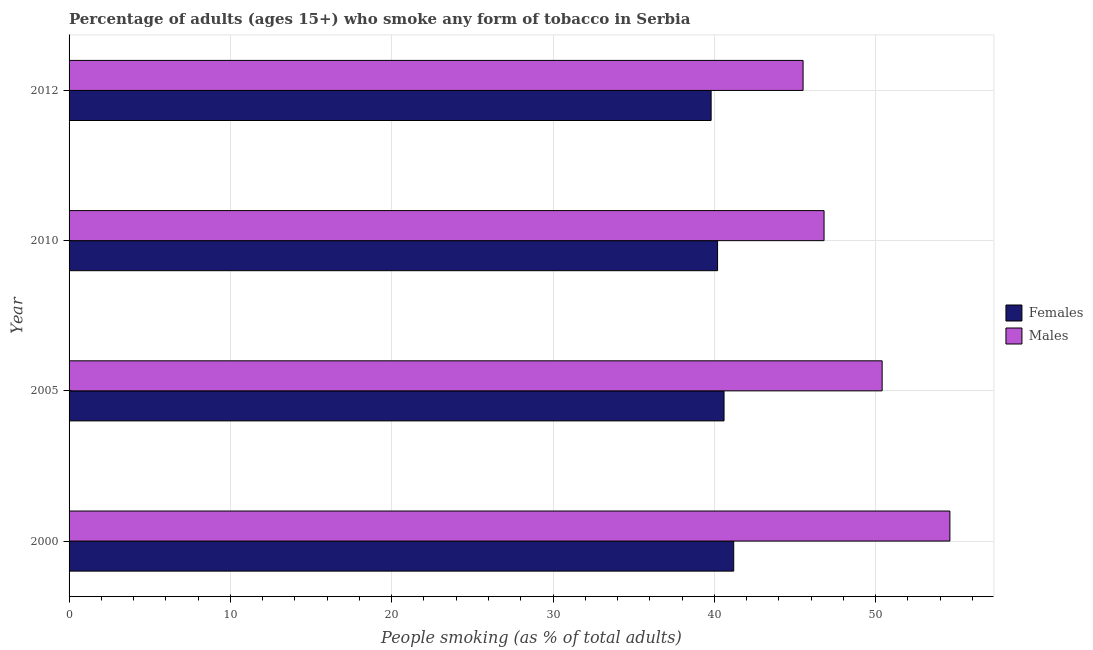How many different coloured bars are there?
Provide a succinct answer. 2. Are the number of bars per tick equal to the number of legend labels?
Give a very brief answer. Yes. What is the label of the 4th group of bars from the top?
Your answer should be very brief. 2000. What is the percentage of males who smoke in 2012?
Your answer should be compact. 45.5. Across all years, what is the maximum percentage of females who smoke?
Offer a very short reply. 41.2. Across all years, what is the minimum percentage of females who smoke?
Keep it short and to the point. 39.8. In which year was the percentage of males who smoke minimum?
Offer a terse response. 2012. What is the total percentage of males who smoke in the graph?
Give a very brief answer. 197.3. What is the difference between the percentage of females who smoke in 2005 and the percentage of males who smoke in 2012?
Offer a very short reply. -4.9. What is the average percentage of females who smoke per year?
Offer a very short reply. 40.45. What is the difference between the highest and the second highest percentage of females who smoke?
Ensure brevity in your answer.  0.6. What does the 1st bar from the top in 2000 represents?
Provide a short and direct response. Males. What does the 2nd bar from the bottom in 2010 represents?
Offer a terse response. Males. Are all the bars in the graph horizontal?
Make the answer very short. Yes. Does the graph contain grids?
Offer a terse response. Yes. Where does the legend appear in the graph?
Provide a succinct answer. Center right. How are the legend labels stacked?
Your answer should be compact. Vertical. What is the title of the graph?
Ensure brevity in your answer.  Percentage of adults (ages 15+) who smoke any form of tobacco in Serbia. Does "Highest 10% of population" appear as one of the legend labels in the graph?
Your answer should be very brief. No. What is the label or title of the X-axis?
Give a very brief answer. People smoking (as % of total adults). What is the People smoking (as % of total adults) of Females in 2000?
Your answer should be very brief. 41.2. What is the People smoking (as % of total adults) of Males in 2000?
Give a very brief answer. 54.6. What is the People smoking (as % of total adults) of Females in 2005?
Offer a terse response. 40.6. What is the People smoking (as % of total adults) in Males in 2005?
Your answer should be very brief. 50.4. What is the People smoking (as % of total adults) of Females in 2010?
Give a very brief answer. 40.2. What is the People smoking (as % of total adults) of Males in 2010?
Your answer should be compact. 46.8. What is the People smoking (as % of total adults) of Females in 2012?
Make the answer very short. 39.8. What is the People smoking (as % of total adults) of Males in 2012?
Your response must be concise. 45.5. Across all years, what is the maximum People smoking (as % of total adults) in Females?
Give a very brief answer. 41.2. Across all years, what is the maximum People smoking (as % of total adults) in Males?
Give a very brief answer. 54.6. Across all years, what is the minimum People smoking (as % of total adults) of Females?
Make the answer very short. 39.8. Across all years, what is the minimum People smoking (as % of total adults) of Males?
Provide a short and direct response. 45.5. What is the total People smoking (as % of total adults) in Females in the graph?
Your response must be concise. 161.8. What is the total People smoking (as % of total adults) of Males in the graph?
Offer a very short reply. 197.3. What is the difference between the People smoking (as % of total adults) in Males in 2000 and that in 2010?
Provide a short and direct response. 7.8. What is the difference between the People smoking (as % of total adults) of Females in 2005 and that in 2010?
Provide a short and direct response. 0.4. What is the difference between the People smoking (as % of total adults) in Females in 2005 and that in 2012?
Make the answer very short. 0.8. What is the difference between the People smoking (as % of total adults) in Males in 2005 and that in 2012?
Provide a short and direct response. 4.9. What is the difference between the People smoking (as % of total adults) in Females in 2010 and that in 2012?
Your response must be concise. 0.4. What is the difference between the People smoking (as % of total adults) in Males in 2010 and that in 2012?
Ensure brevity in your answer.  1.3. What is the difference between the People smoking (as % of total adults) of Females in 2005 and the People smoking (as % of total adults) of Males in 2012?
Your answer should be very brief. -4.9. What is the average People smoking (as % of total adults) of Females per year?
Make the answer very short. 40.45. What is the average People smoking (as % of total adults) of Males per year?
Offer a very short reply. 49.33. In the year 2012, what is the difference between the People smoking (as % of total adults) in Females and People smoking (as % of total adults) in Males?
Keep it short and to the point. -5.7. What is the ratio of the People smoking (as % of total adults) in Females in 2000 to that in 2005?
Provide a short and direct response. 1.01. What is the ratio of the People smoking (as % of total adults) in Males in 2000 to that in 2005?
Offer a very short reply. 1.08. What is the ratio of the People smoking (as % of total adults) of Females in 2000 to that in 2010?
Ensure brevity in your answer.  1.02. What is the ratio of the People smoking (as % of total adults) in Males in 2000 to that in 2010?
Your response must be concise. 1.17. What is the ratio of the People smoking (as % of total adults) in Females in 2000 to that in 2012?
Provide a succinct answer. 1.04. What is the ratio of the People smoking (as % of total adults) of Males in 2000 to that in 2012?
Your answer should be compact. 1.2. What is the ratio of the People smoking (as % of total adults) of Females in 2005 to that in 2012?
Your answer should be compact. 1.02. What is the ratio of the People smoking (as % of total adults) of Males in 2005 to that in 2012?
Keep it short and to the point. 1.11. What is the ratio of the People smoking (as % of total adults) in Females in 2010 to that in 2012?
Give a very brief answer. 1.01. What is the ratio of the People smoking (as % of total adults) in Males in 2010 to that in 2012?
Give a very brief answer. 1.03. What is the difference between the highest and the second highest People smoking (as % of total adults) of Males?
Your response must be concise. 4.2. What is the difference between the highest and the lowest People smoking (as % of total adults) in Females?
Offer a very short reply. 1.4. 